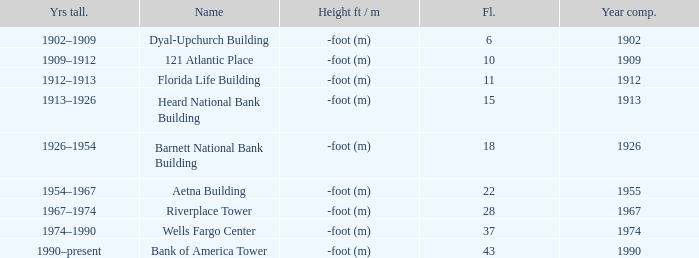How tall is the florida life building, completed before 1990? -foot (m). Write the full table. {'header': ['Yrs tall.', 'Name', 'Height ft / m', 'Fl.', 'Year comp.'], 'rows': [['1902–1909', 'Dyal-Upchurch Building', '-foot (m)', '6', '1902'], ['1909–1912', '121 Atlantic Place', '-foot (m)', '10', '1909'], ['1912–1913', 'Florida Life Building', '-foot (m)', '11', '1912'], ['1913–1926', 'Heard National Bank Building', '-foot (m)', '15', '1913'], ['1926–1954', 'Barnett National Bank Building', '-foot (m)', '18', '1926'], ['1954–1967', 'Aetna Building', '-foot (m)', '22', '1955'], ['1967–1974', 'Riverplace Tower', '-foot (m)', '28', '1967'], ['1974–1990', 'Wells Fargo Center', '-foot (m)', '37', '1974'], ['1990–present', 'Bank of America Tower', '-foot (m)', '43', '1990']]} 